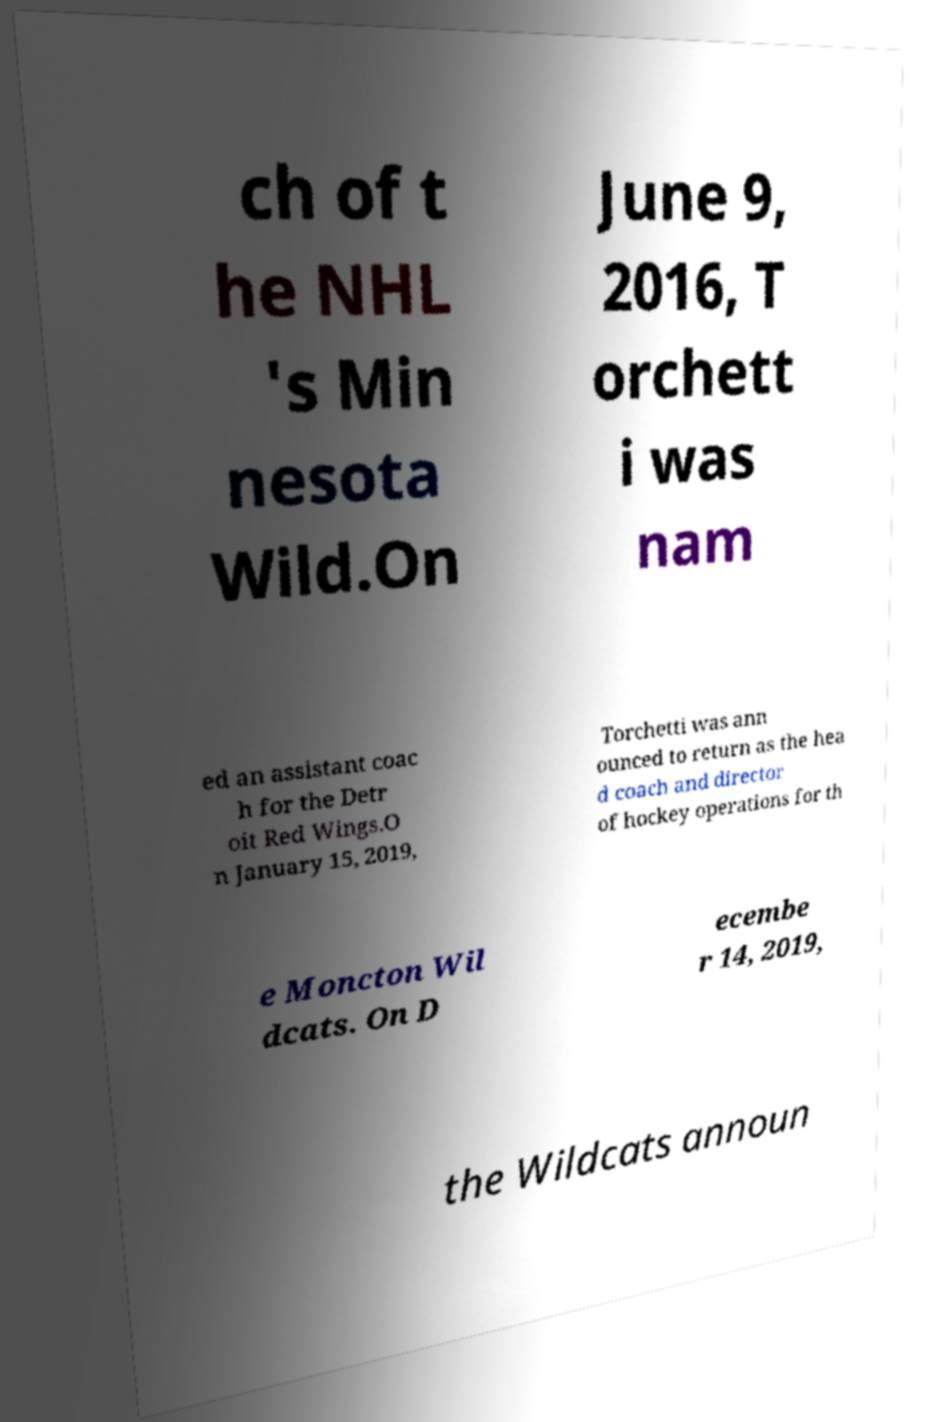Could you assist in decoding the text presented in this image and type it out clearly? ch of t he NHL 's Min nesota Wild.On June 9, 2016, T orchett i was nam ed an assistant coac h for the Detr oit Red Wings.O n January 15, 2019, Torchetti was ann ounced to return as the hea d coach and director of hockey operations for th e Moncton Wil dcats. On D ecembe r 14, 2019, the Wildcats announ 